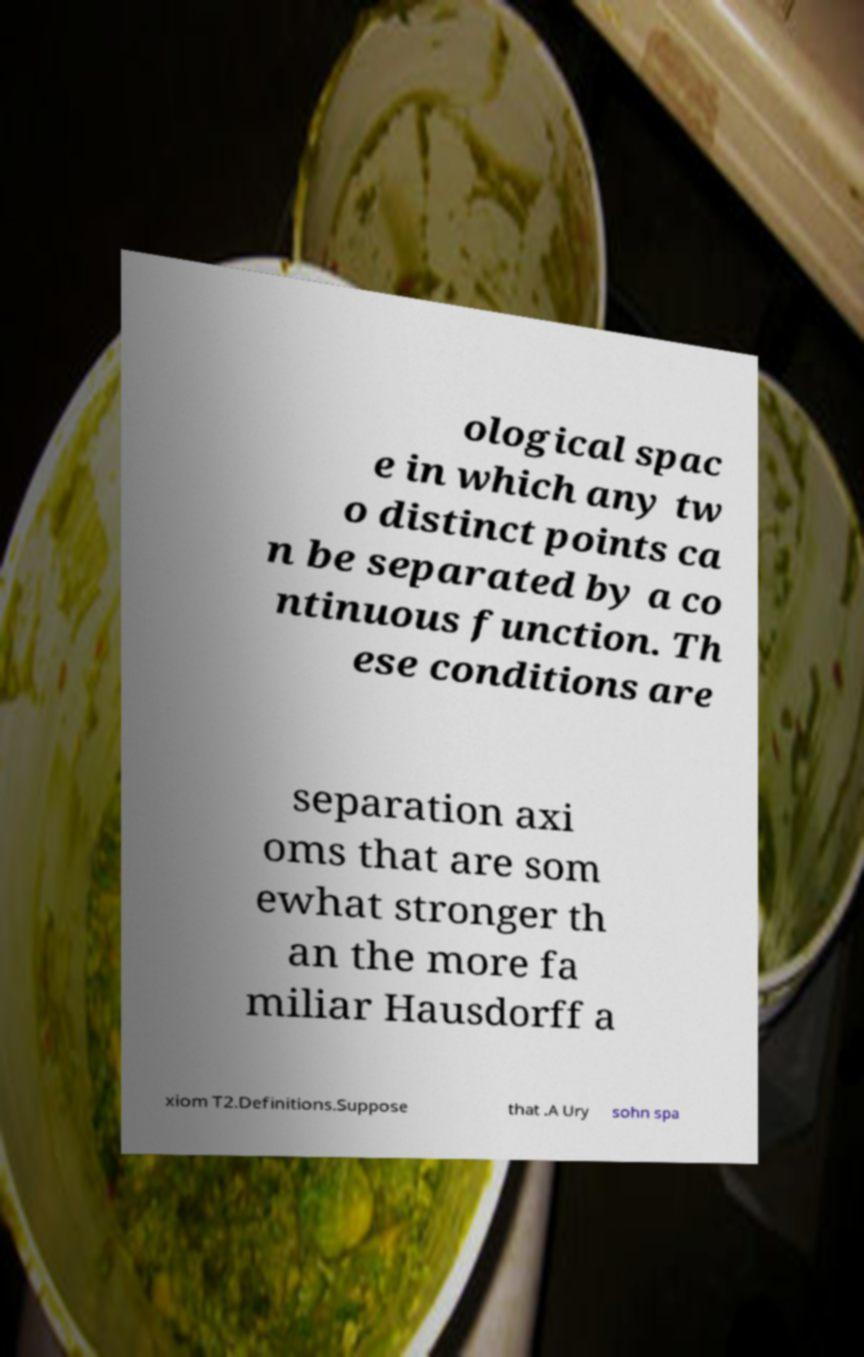For documentation purposes, I need the text within this image transcribed. Could you provide that? ological spac e in which any tw o distinct points ca n be separated by a co ntinuous function. Th ese conditions are separation axi oms that are som ewhat stronger th an the more fa miliar Hausdorff a xiom T2.Definitions.Suppose that .A Ury sohn spa 